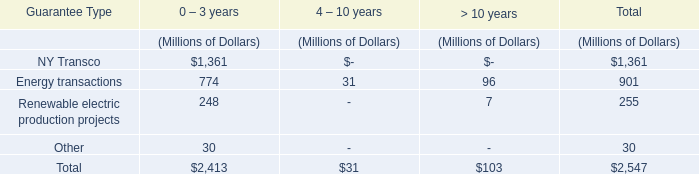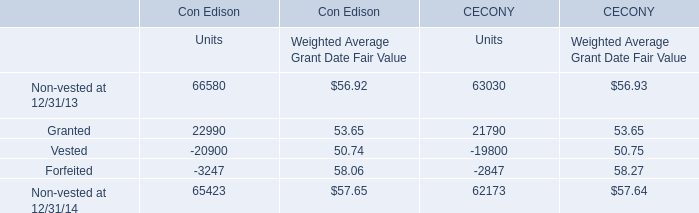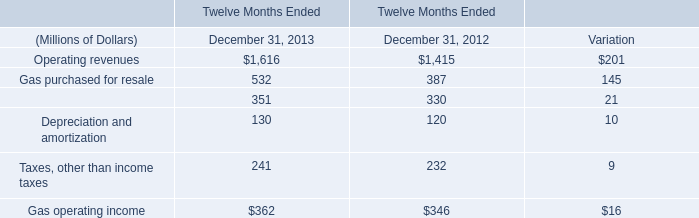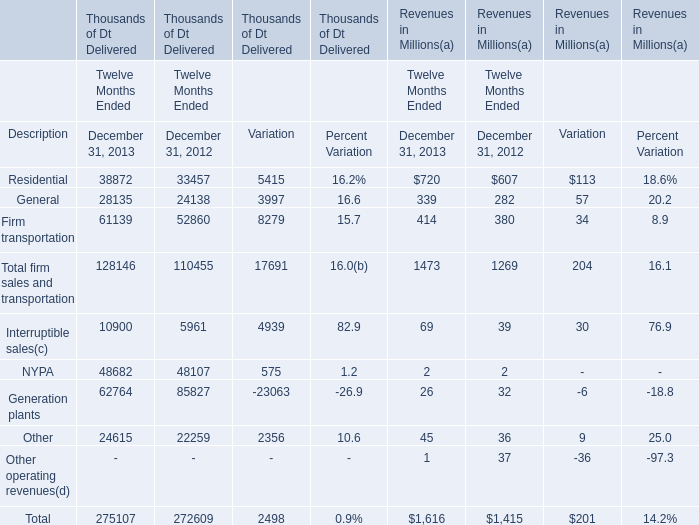Which year is Generation plants the lowest for Revenues ? 
Answer: 2013. 